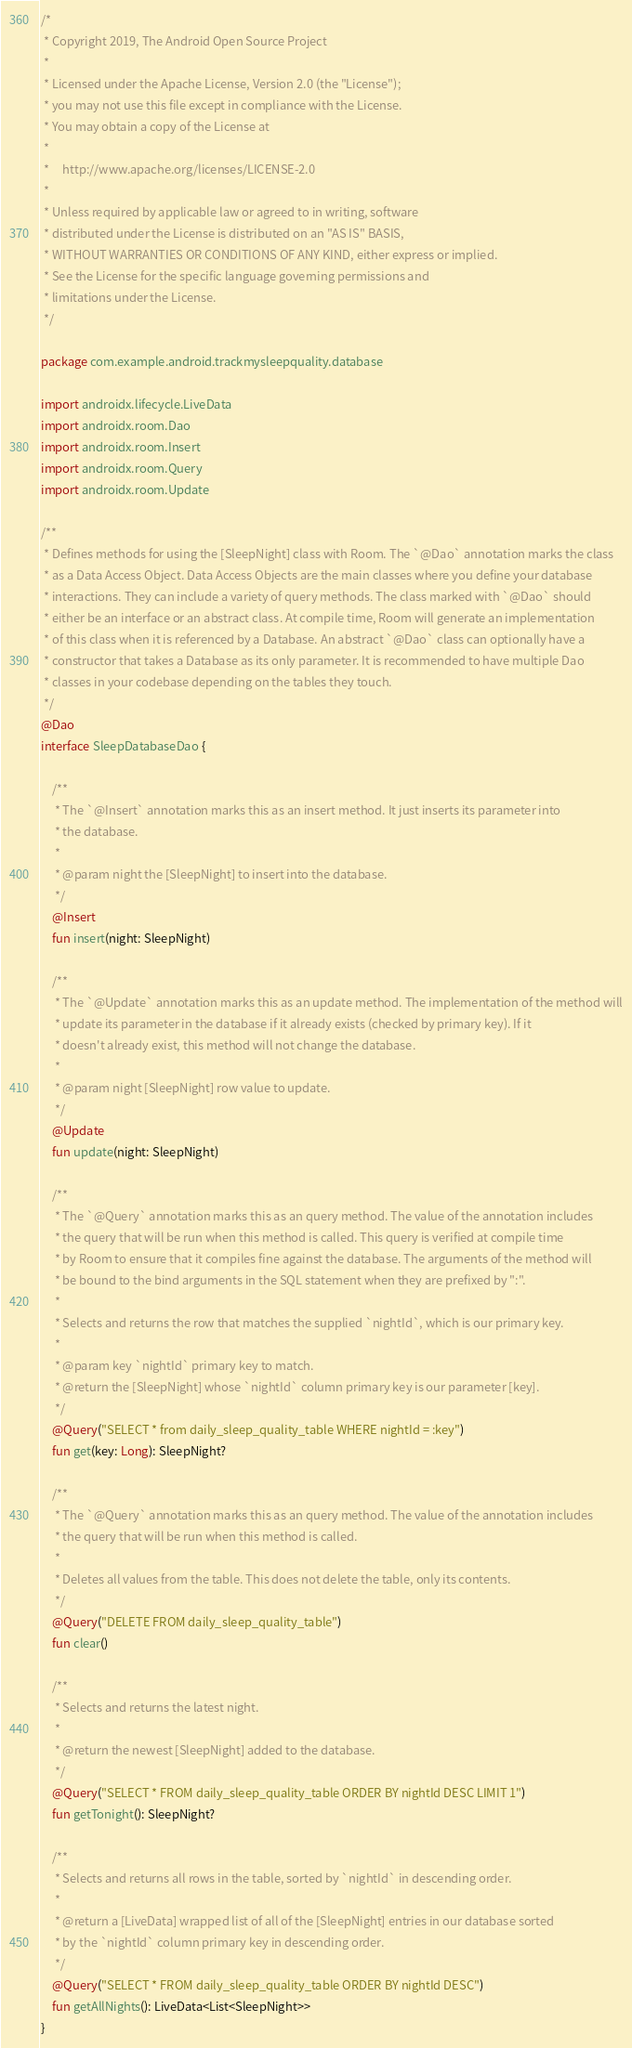Convert code to text. <code><loc_0><loc_0><loc_500><loc_500><_Kotlin_>/*
 * Copyright 2019, The Android Open Source Project
 *
 * Licensed under the Apache License, Version 2.0 (the "License");
 * you may not use this file except in compliance with the License.
 * You may obtain a copy of the License at
 *
 *     http://www.apache.org/licenses/LICENSE-2.0
 *
 * Unless required by applicable law or agreed to in writing, software
 * distributed under the License is distributed on an "AS IS" BASIS,
 * WITHOUT WARRANTIES OR CONDITIONS OF ANY KIND, either express or implied.
 * See the License for the specific language governing permissions and
 * limitations under the License.
 */

package com.example.android.trackmysleepquality.database

import androidx.lifecycle.LiveData
import androidx.room.Dao
import androidx.room.Insert
import androidx.room.Query
import androidx.room.Update

/**
 * Defines methods for using the [SleepNight] class with Room. The `@Dao` annotation marks the class
 * as a Data Access Object. Data Access Objects are the main classes where you define your database
 * interactions. They can include a variety of query methods. The class marked with `@Dao` should
 * either be an interface or an abstract class. At compile time, Room will generate an implementation
 * of this class when it is referenced by a Database. An abstract `@Dao` class can optionally have a
 * constructor that takes a Database as its only parameter. It is recommended to have multiple Dao
 * classes in your codebase depending on the tables they touch.
 */
@Dao
interface SleepDatabaseDao {

    /**
     * The `@Insert` annotation marks this as an insert method. It just inserts its parameter into
     * the database.
     *
     * @param night the [SleepNight] to insert into the database.
     */
    @Insert
    fun insert(night: SleepNight)

    /**
     * The `@Update` annotation marks this as an update method. The implementation of the method will
     * update its parameter in the database if it already exists (checked by primary key). If it
     * doesn't already exist, this method will not change the database.
     *
     * @param night [SleepNight] row value to update.
     */
    @Update
    fun update(night: SleepNight)

    /**
     * The `@Query` annotation marks this as an query method. The value of the annotation includes
     * the query that will be run when this method is called. This query is verified at compile time
     * by Room to ensure that it compiles fine against the database. The arguments of the method will
     * be bound to the bind arguments in the SQL statement when they are prefixed by ":".
     *
     * Selects and returns the row that matches the supplied `nightId`, which is our primary key.
     *
     * @param key `nightId` primary key to match.
     * @return the [SleepNight] whose `nightId` column primary key is our parameter [key].
     */
    @Query("SELECT * from daily_sleep_quality_table WHERE nightId = :key")
    fun get(key: Long): SleepNight?

    /**
     * The `@Query` annotation marks this as an query method. The value of the annotation includes
     * the query that will be run when this method is called.
     *
     * Deletes all values from the table. This does not delete the table, only its contents.
     */
    @Query("DELETE FROM daily_sleep_quality_table")
    fun clear()

    /**
     * Selects and returns the latest night.
     *
     * @return the newest [SleepNight] added to the database.
     */
    @Query("SELECT * FROM daily_sleep_quality_table ORDER BY nightId DESC LIMIT 1")
    fun getTonight(): SleepNight?

    /**
     * Selects and returns all rows in the table, sorted by `nightId` in descending order.
     *
     * @return a [LiveData] wrapped list of all of the [SleepNight] entries in our database sorted
     * by the `nightId` column primary key in descending order.
     */
    @Query("SELECT * FROM daily_sleep_quality_table ORDER BY nightId DESC")
    fun getAllNights(): LiveData<List<SleepNight>>
}</code> 